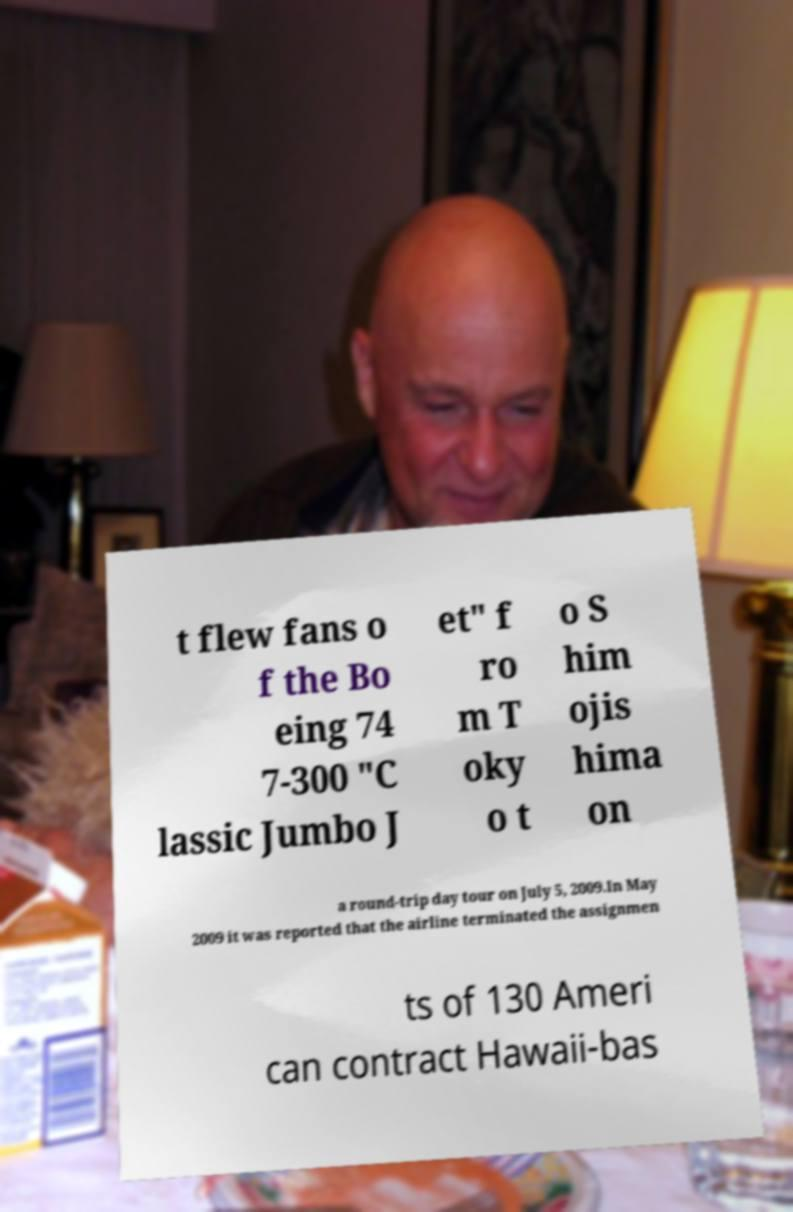What messages or text are displayed in this image? I need them in a readable, typed format. t flew fans o f the Bo eing 74 7-300 "C lassic Jumbo J et" f ro m T oky o t o S him ojis hima on a round-trip day tour on July 5, 2009.In May 2009 it was reported that the airline terminated the assignmen ts of 130 Ameri can contract Hawaii-bas 